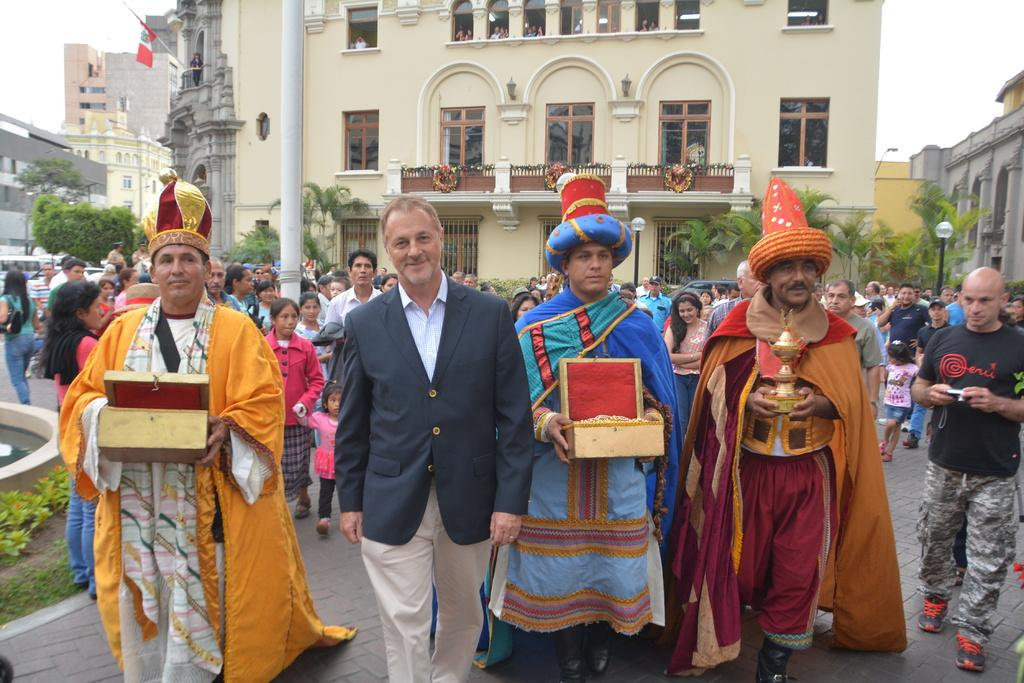What are the people in the image doing? There are many persons walking on the road in the image. What can be seen in the background of the image? There is a pillar, buildings, a flag, and the sky visible in the background of the image. What type of page is being turned in the image? There is no page present in the image; it features people walking on the road and a background with a pillar, buildings, a flag, and the sky. 